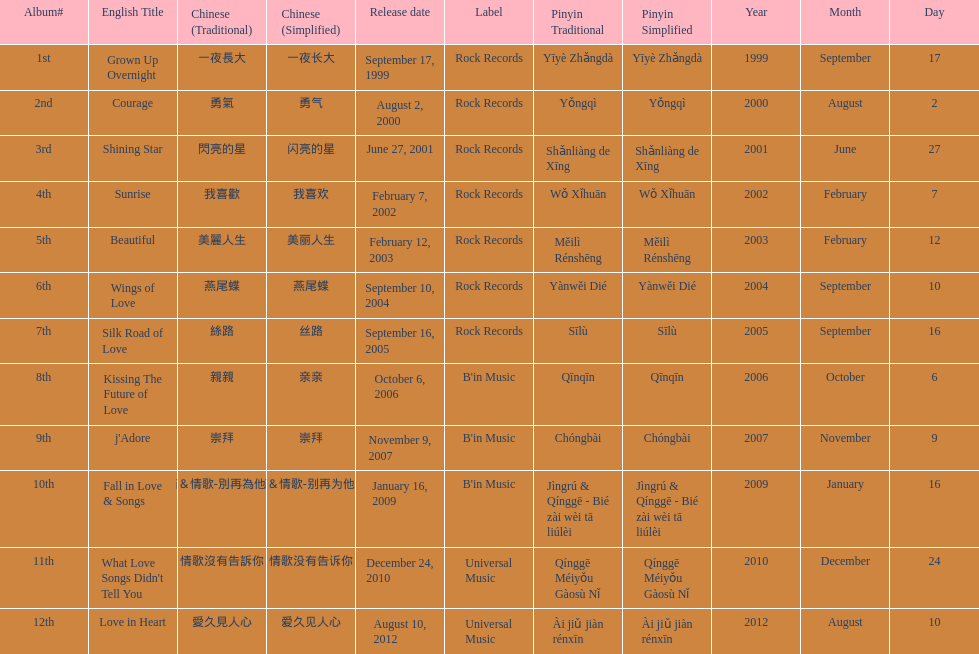Which album was released later, beautiful, or j'adore? J'adore. 